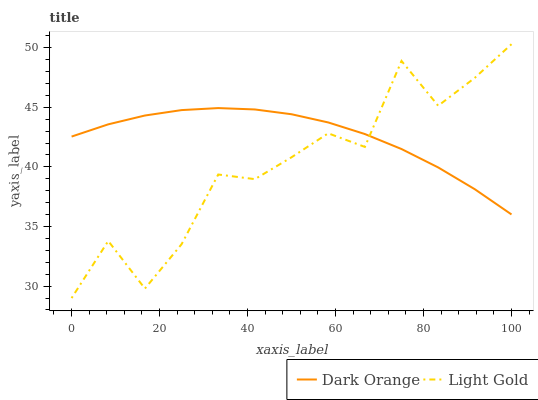Does Light Gold have the minimum area under the curve?
Answer yes or no. Yes. Does Dark Orange have the maximum area under the curve?
Answer yes or no. Yes. Does Light Gold have the maximum area under the curve?
Answer yes or no. No. Is Dark Orange the smoothest?
Answer yes or no. Yes. Is Light Gold the roughest?
Answer yes or no. Yes. Is Light Gold the smoothest?
Answer yes or no. No. Does Light Gold have the lowest value?
Answer yes or no. Yes. Does Light Gold have the highest value?
Answer yes or no. Yes. Does Light Gold intersect Dark Orange?
Answer yes or no. Yes. Is Light Gold less than Dark Orange?
Answer yes or no. No. Is Light Gold greater than Dark Orange?
Answer yes or no. No. 